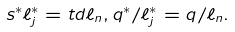Convert formula to latex. <formula><loc_0><loc_0><loc_500><loc_500>s ^ { * } \ell _ { j } ^ { * } = t d \ell _ { n } , q ^ { * } / \ell _ { j } ^ { * } = q / \ell _ { n } .</formula> 